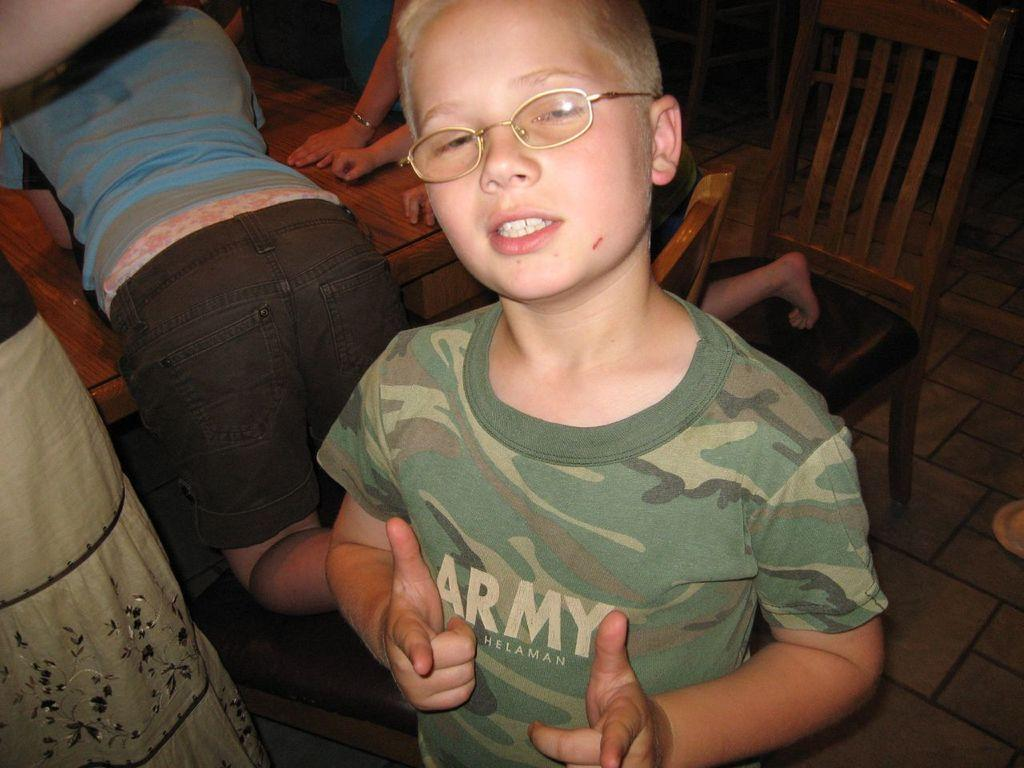Who is the main subject in the image? There is a boy in the image. What is the boy wearing? The boy is wearing a green t-shirt. What is the boy's expression in the image? The boy is laughing. What can be seen in the background of the image? There are persons lying on a wooden table in the background. What type of furniture is present in the image? There are chairs and a stool in the image. What part of the room is visible in the image? The floor is visible in the image. What type of sea creatures can be seen swimming near the boy in the image? There are no sea creatures present in the image; it is set indoors with no reference to a seashore. 